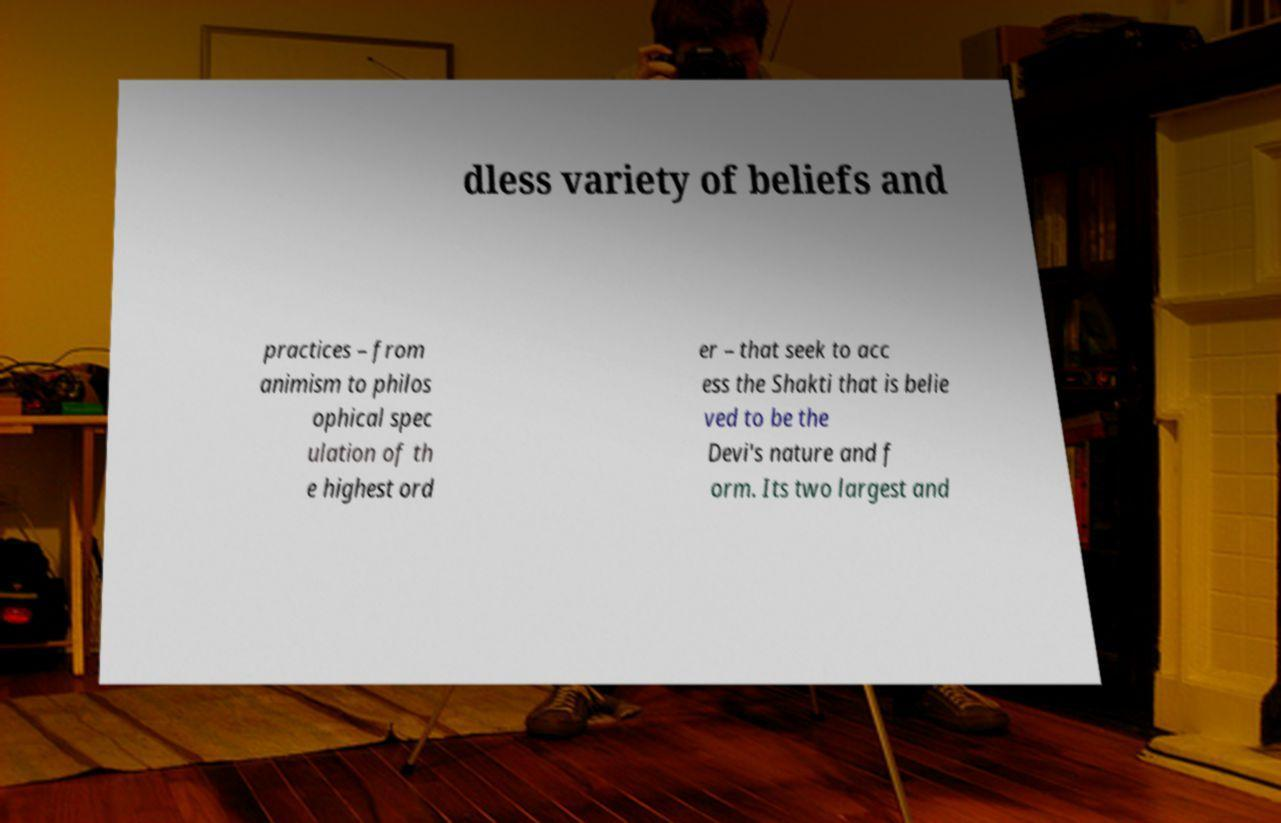Please read and relay the text visible in this image. What does it say? dless variety of beliefs and practices – from animism to philos ophical spec ulation of th e highest ord er – that seek to acc ess the Shakti that is belie ved to be the Devi's nature and f orm. Its two largest and 